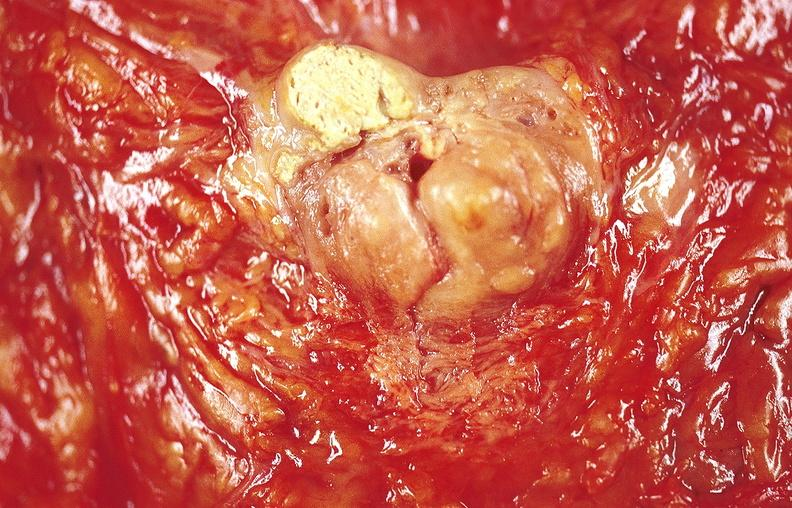s papillary adenoma present?
Answer the question using a single word or phrase. No 